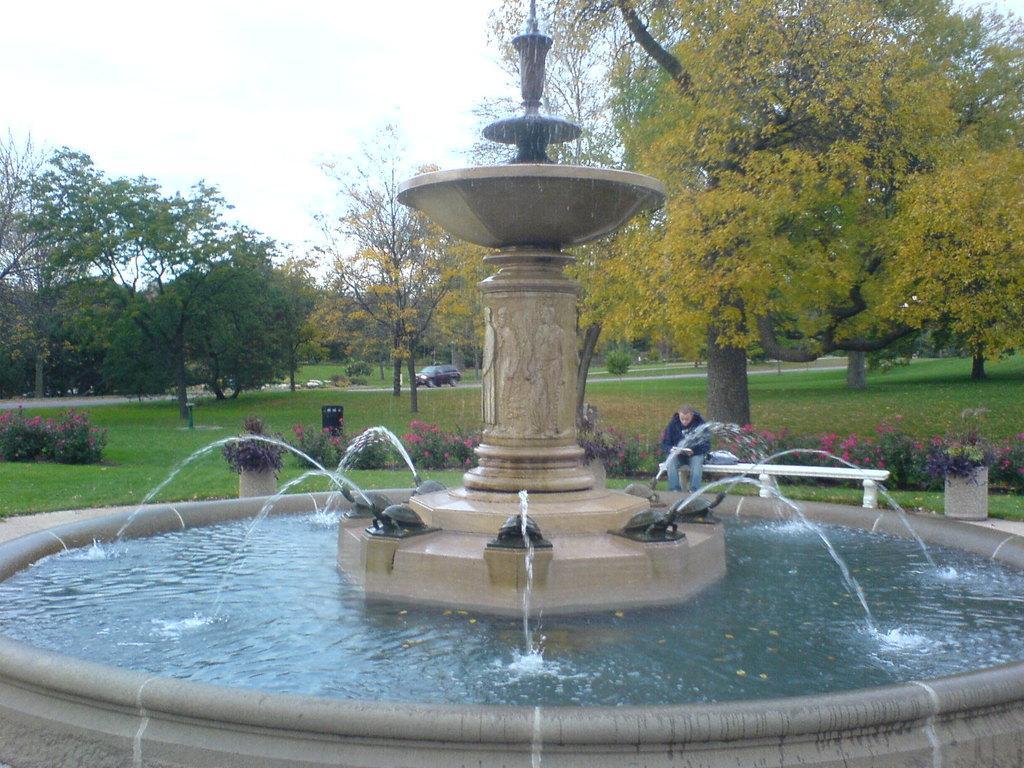Can you describe this image briefly? In this image I can see the fountain which is brown in color and I can see some water in the fountain. In the background I can see a person sitting on a white colored bench, few trees, few vehicles on the road, some grass, few plants, a bin which is black in color and the sky. 